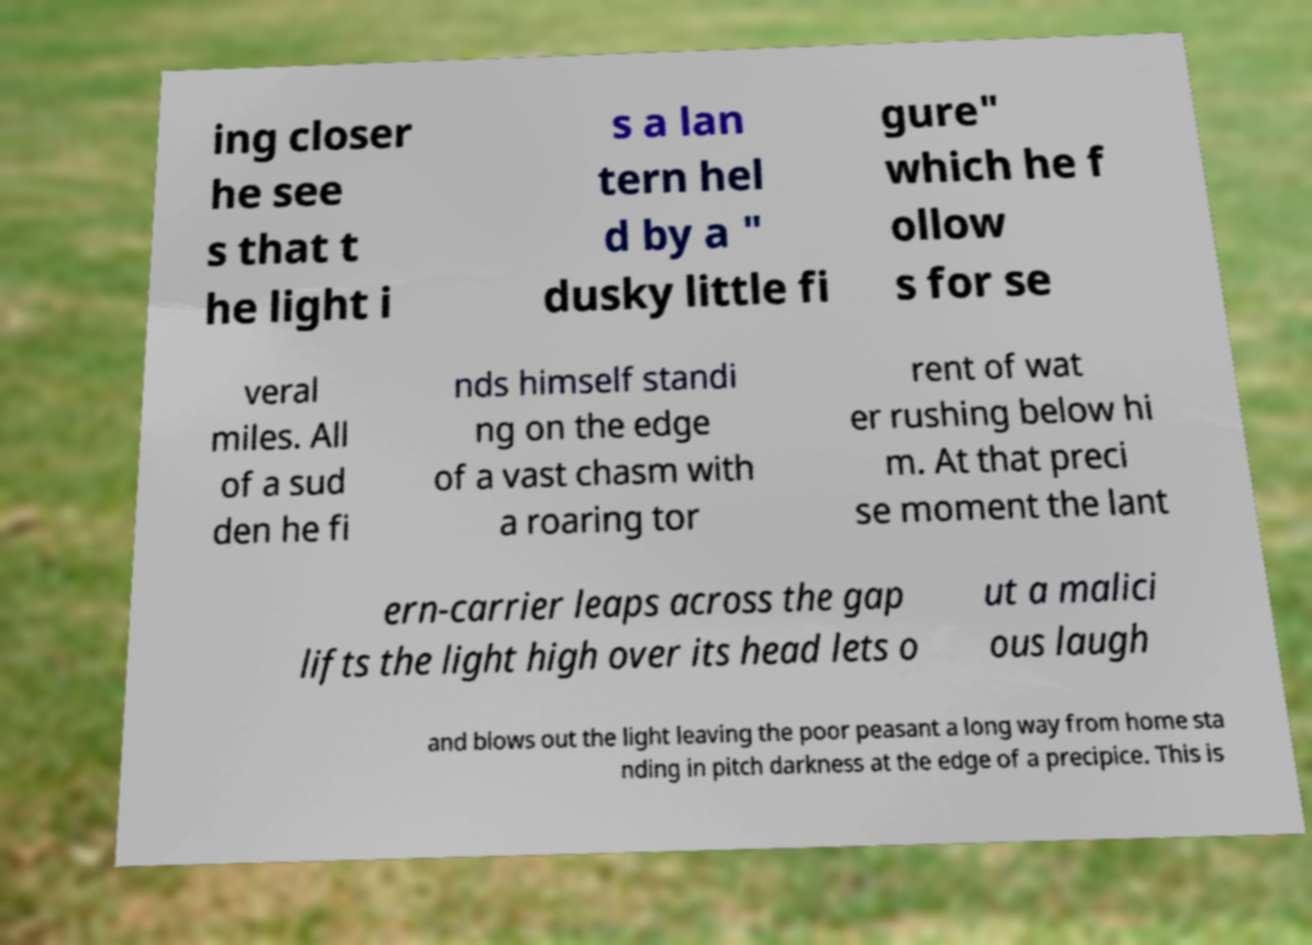What messages or text are displayed in this image? I need them in a readable, typed format. ing closer he see s that t he light i s a lan tern hel d by a " dusky little fi gure" which he f ollow s for se veral miles. All of a sud den he fi nds himself standi ng on the edge of a vast chasm with a roaring tor rent of wat er rushing below hi m. At that preci se moment the lant ern-carrier leaps across the gap lifts the light high over its head lets o ut a malici ous laugh and blows out the light leaving the poor peasant a long way from home sta nding in pitch darkness at the edge of a precipice. This is 